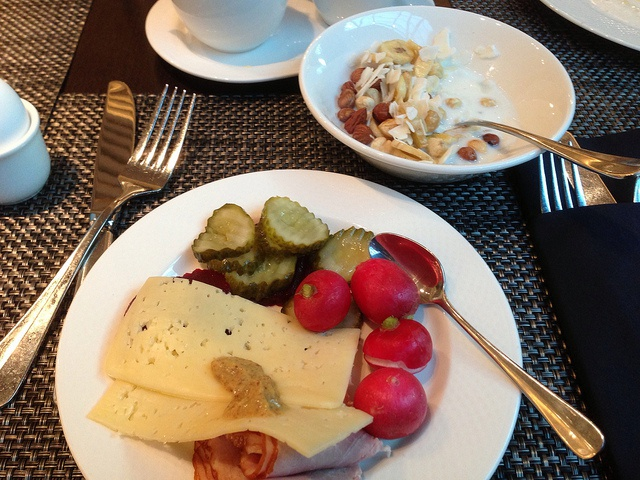Describe the objects in this image and their specific colors. I can see dining table in black, lightgray, tan, and maroon tones, bowl in maroon, lightgray, tan, and lightblue tones, fork in maroon, ivory, gray, and tan tones, spoon in maroon, gray, brown, and tan tones, and cup in maroon, darkgray, tan, gray, and lightblue tones in this image. 